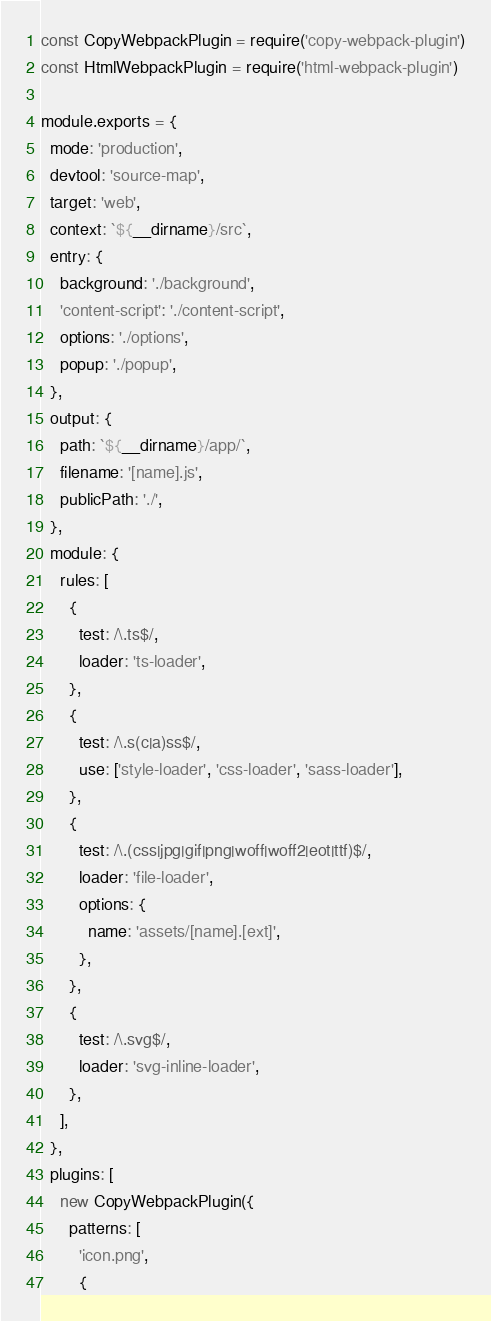Convert code to text. <code><loc_0><loc_0><loc_500><loc_500><_JavaScript_>const CopyWebpackPlugin = require('copy-webpack-plugin')
const HtmlWebpackPlugin = require('html-webpack-plugin')

module.exports = {
  mode: 'production',
  devtool: 'source-map',
  target: 'web',
  context: `${__dirname}/src`,
  entry: {
    background: './background',
    'content-script': './content-script',
    options: './options',
    popup: './popup',
  },
  output: {
    path: `${__dirname}/app/`,
    filename: '[name].js',
    publicPath: './',
  },
  module: {
    rules: [
      {
        test: /\.ts$/,
        loader: 'ts-loader',
      },
      {
        test: /\.s(c|a)ss$/,
        use: ['style-loader', 'css-loader', 'sass-loader'],
      },
      {
        test: /\.(css|jpg|gif|png|woff|woff2|eot|ttf)$/,
        loader: 'file-loader',
        options: {
          name: 'assets/[name].[ext]',
        },
      },
      {
        test: /\.svg$/,
        loader: 'svg-inline-loader',
      },
    ],
  },
  plugins: [
    new CopyWebpackPlugin({
      patterns: [
        'icon.png',
        {</code> 